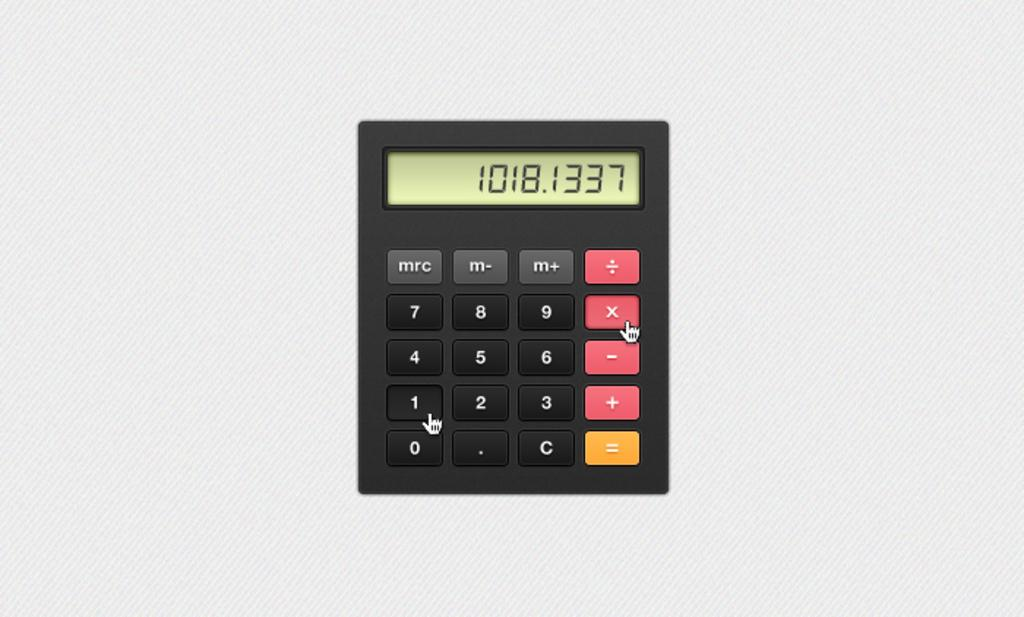Provide a one-sentence caption for the provided image. A calculator shows the number 1018.1337 on the screen. 